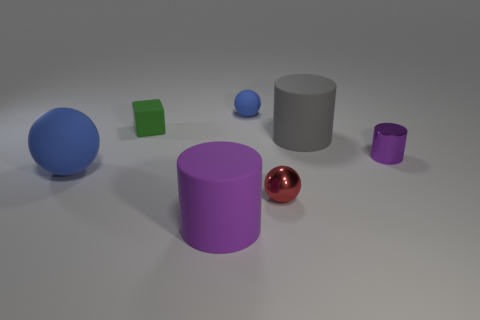Add 3 tiny purple blocks. How many objects exist? 10 Subtract all cylinders. How many objects are left? 4 Add 4 tiny matte cubes. How many tiny matte cubes are left? 5 Add 4 small gray things. How many small gray things exist? 4 Subtract 2 purple cylinders. How many objects are left? 5 Subtract all tiny cylinders. Subtract all tiny cubes. How many objects are left? 5 